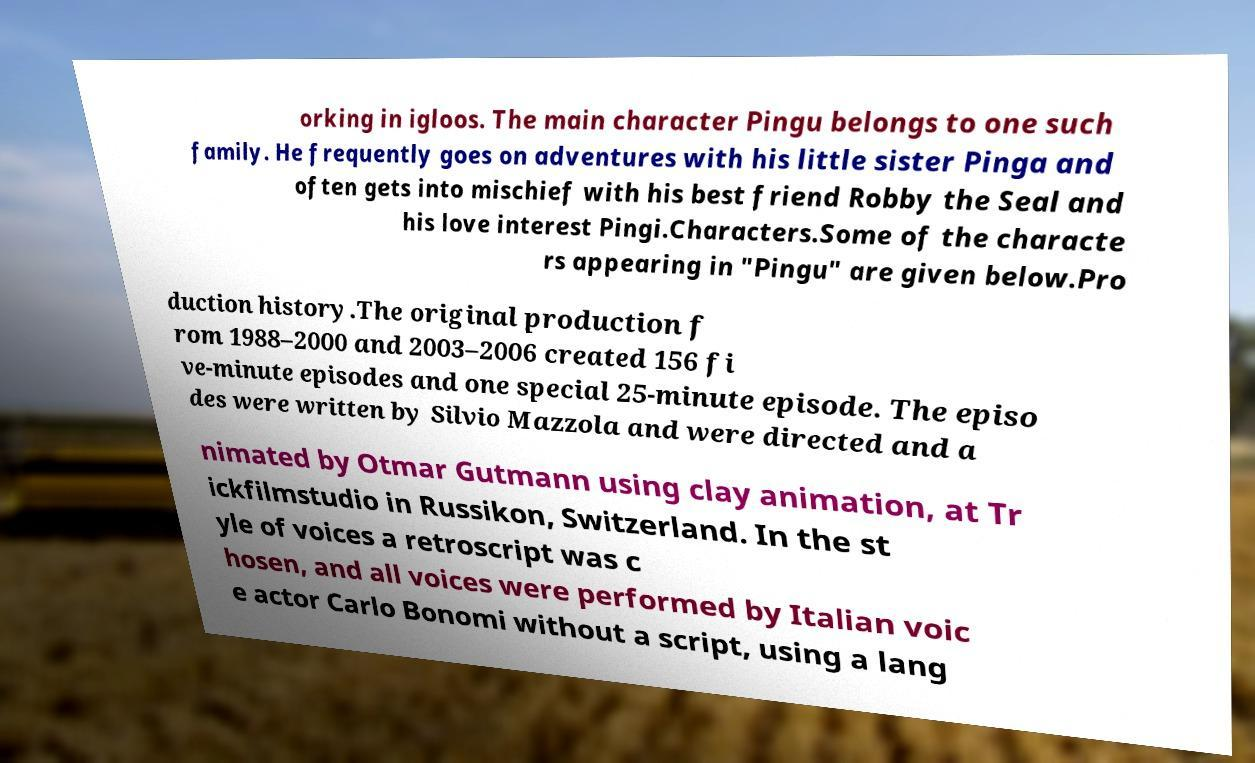There's text embedded in this image that I need extracted. Can you transcribe it verbatim? orking in igloos. The main character Pingu belongs to one such family. He frequently goes on adventures with his little sister Pinga and often gets into mischief with his best friend Robby the Seal and his love interest Pingi.Characters.Some of the characte rs appearing in "Pingu" are given below.Pro duction history.The original production f rom 1988–2000 and 2003–2006 created 156 fi ve-minute episodes and one special 25-minute episode. The episo des were written by Silvio Mazzola and were directed and a nimated by Otmar Gutmann using clay animation, at Tr ickfilmstudio in Russikon, Switzerland. In the st yle of voices a retroscript was c hosen, and all voices were performed by Italian voic e actor Carlo Bonomi without a script, using a lang 